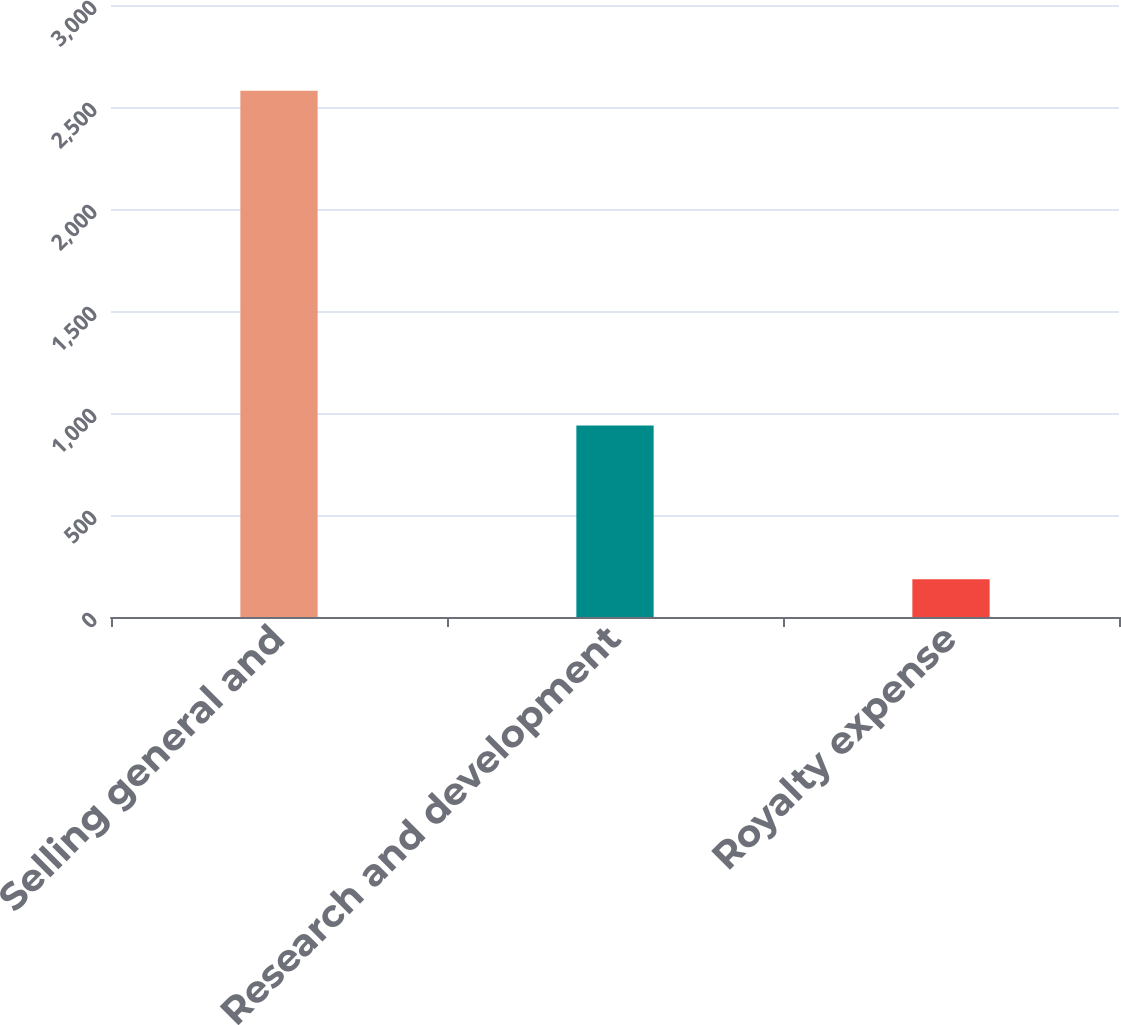<chart> <loc_0><loc_0><loc_500><loc_500><bar_chart><fcel>Selling general and<fcel>Research and development<fcel>Royalty expense<nl><fcel>2580<fcel>939<fcel>185<nl></chart> 